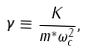Convert formula to latex. <formula><loc_0><loc_0><loc_500><loc_500>\gamma \equiv \frac { K } { m ^ { * } \omega _ { c } ^ { 2 } } ,</formula> 